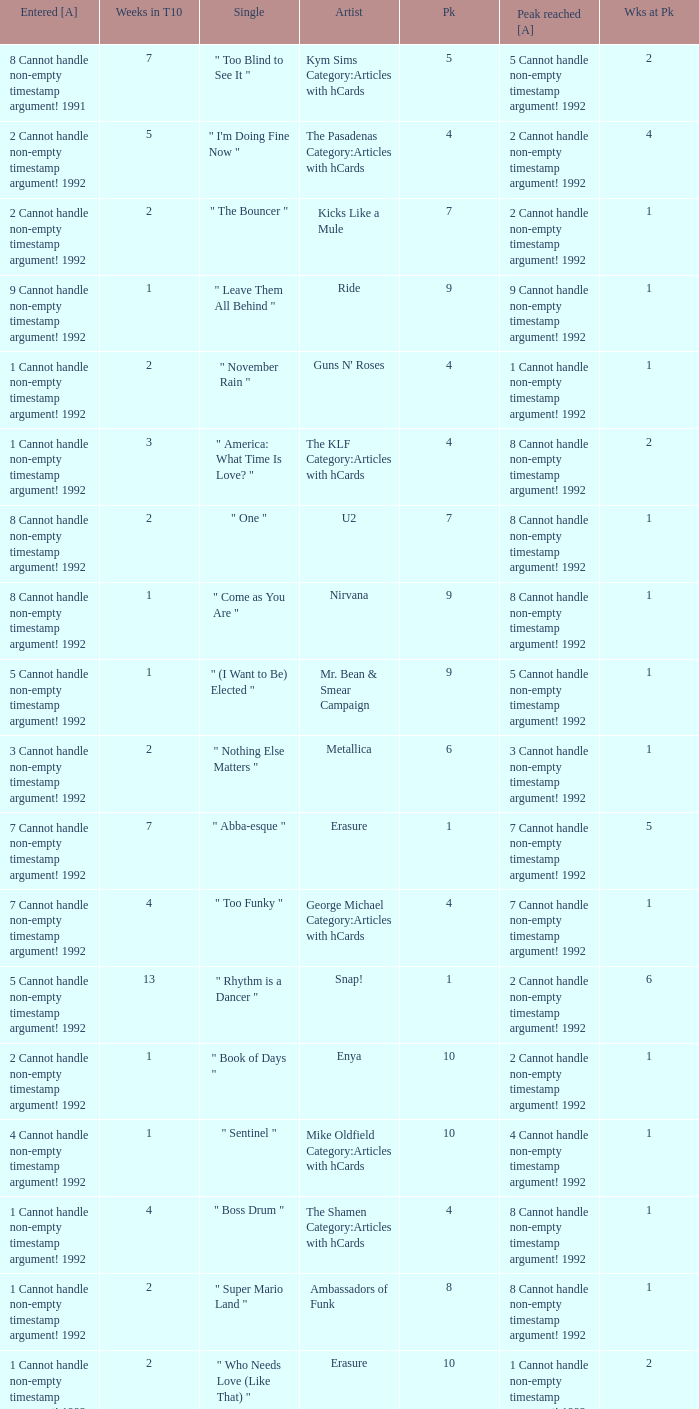Would you be able to parse every entry in this table? {'header': ['Entered [A]', 'Weeks in T10', 'Single', 'Artist', 'Pk', 'Peak reached [A]', 'Wks at Pk'], 'rows': [['8 Cannot handle non-empty timestamp argument! 1991', '7', '" Too Blind to See It "', 'Kym Sims Category:Articles with hCards', '5', '5 Cannot handle non-empty timestamp argument! 1992', '2'], ['2 Cannot handle non-empty timestamp argument! 1992', '5', '" I\'m Doing Fine Now "', 'The Pasadenas Category:Articles with hCards', '4', '2 Cannot handle non-empty timestamp argument! 1992', '4'], ['2 Cannot handle non-empty timestamp argument! 1992', '2', '" The Bouncer "', 'Kicks Like a Mule', '7', '2 Cannot handle non-empty timestamp argument! 1992', '1'], ['9 Cannot handle non-empty timestamp argument! 1992', '1', '" Leave Them All Behind "', 'Ride', '9', '9 Cannot handle non-empty timestamp argument! 1992', '1'], ['1 Cannot handle non-empty timestamp argument! 1992', '2', '" November Rain "', "Guns N' Roses", '4', '1 Cannot handle non-empty timestamp argument! 1992', '1'], ['1 Cannot handle non-empty timestamp argument! 1992', '3', '" America: What Time Is Love? "', 'The KLF Category:Articles with hCards', '4', '8 Cannot handle non-empty timestamp argument! 1992', '2'], ['8 Cannot handle non-empty timestamp argument! 1992', '2', '" One "', 'U2', '7', '8 Cannot handle non-empty timestamp argument! 1992', '1'], ['8 Cannot handle non-empty timestamp argument! 1992', '1', '" Come as You Are "', 'Nirvana', '9', '8 Cannot handle non-empty timestamp argument! 1992', '1'], ['5 Cannot handle non-empty timestamp argument! 1992', '1', '" (I Want to Be) Elected "', 'Mr. Bean & Smear Campaign', '9', '5 Cannot handle non-empty timestamp argument! 1992', '1'], ['3 Cannot handle non-empty timestamp argument! 1992', '2', '" Nothing Else Matters "', 'Metallica', '6', '3 Cannot handle non-empty timestamp argument! 1992', '1'], ['7 Cannot handle non-empty timestamp argument! 1992', '7', '" Abba-esque "', 'Erasure', '1', '7 Cannot handle non-empty timestamp argument! 1992', '5'], ['7 Cannot handle non-empty timestamp argument! 1992', '4', '" Too Funky "', 'George Michael Category:Articles with hCards', '4', '7 Cannot handle non-empty timestamp argument! 1992', '1'], ['5 Cannot handle non-empty timestamp argument! 1992', '13', '" Rhythm is a Dancer "', 'Snap!', '1', '2 Cannot handle non-empty timestamp argument! 1992', '6'], ['2 Cannot handle non-empty timestamp argument! 1992', '1', '" Book of Days "', 'Enya', '10', '2 Cannot handle non-empty timestamp argument! 1992', '1'], ['4 Cannot handle non-empty timestamp argument! 1992', '1', '" Sentinel "', 'Mike Oldfield Category:Articles with hCards', '10', '4 Cannot handle non-empty timestamp argument! 1992', '1'], ['1 Cannot handle non-empty timestamp argument! 1992', '4', '" Boss Drum "', 'The Shamen Category:Articles with hCards', '4', '8 Cannot handle non-empty timestamp argument! 1992', '1'], ['1 Cannot handle non-empty timestamp argument! 1992', '2', '" Super Mario Land "', 'Ambassadors of Funk', '8', '8 Cannot handle non-empty timestamp argument! 1992', '1'], ['1 Cannot handle non-empty timestamp argument! 1992', '2', '" Who Needs Love (Like That) "', 'Erasure', '10', '1 Cannot handle non-empty timestamp argument! 1992', '2'], ['8 Cannot handle non-empty timestamp argument! 1992', '2', '" Be My Baby "', 'Vanessa Paradis Category:Articles with hCards', '6', '8 Cannot handle non-empty timestamp argument! 1992', '1'], ['6 Cannot handle non-empty timestamp argument! 1992', '5', '" Slam Jam "', 'WWF Superstars', '4', '6 Cannot handle non-empty timestamp argument! 1992', '2']]} If the peak is 9, how many weeks was it in the top 10? 1.0. 